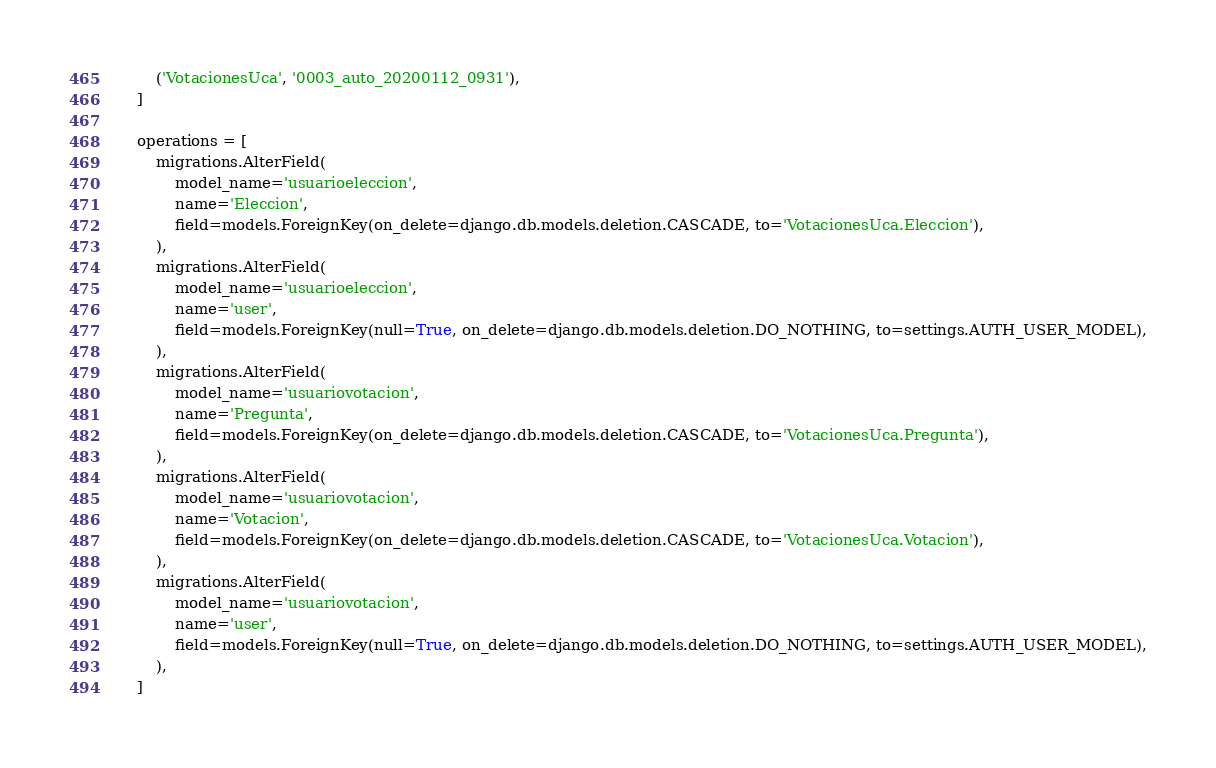Convert code to text. <code><loc_0><loc_0><loc_500><loc_500><_Python_>        ('VotacionesUca', '0003_auto_20200112_0931'),
    ]

    operations = [
        migrations.AlterField(
            model_name='usuarioeleccion',
            name='Eleccion',
            field=models.ForeignKey(on_delete=django.db.models.deletion.CASCADE, to='VotacionesUca.Eleccion'),
        ),
        migrations.AlterField(
            model_name='usuarioeleccion',
            name='user',
            field=models.ForeignKey(null=True, on_delete=django.db.models.deletion.DO_NOTHING, to=settings.AUTH_USER_MODEL),
        ),
        migrations.AlterField(
            model_name='usuariovotacion',
            name='Pregunta',
            field=models.ForeignKey(on_delete=django.db.models.deletion.CASCADE, to='VotacionesUca.Pregunta'),
        ),
        migrations.AlterField(
            model_name='usuariovotacion',
            name='Votacion',
            field=models.ForeignKey(on_delete=django.db.models.deletion.CASCADE, to='VotacionesUca.Votacion'),
        ),
        migrations.AlterField(
            model_name='usuariovotacion',
            name='user',
            field=models.ForeignKey(null=True, on_delete=django.db.models.deletion.DO_NOTHING, to=settings.AUTH_USER_MODEL),
        ),
    ]
</code> 